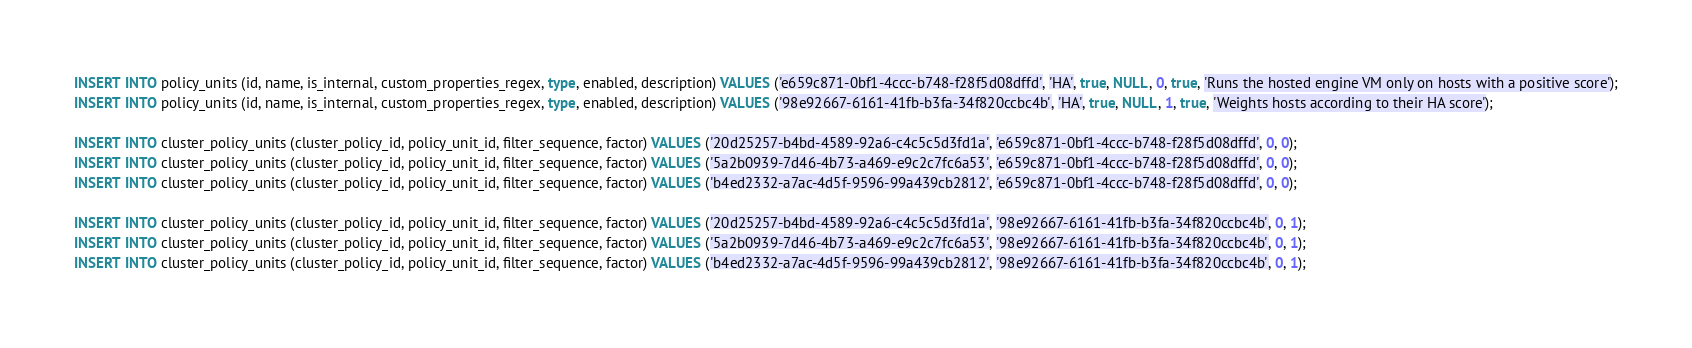Convert code to text. <code><loc_0><loc_0><loc_500><loc_500><_SQL_>
INSERT INTO policy_units (id, name, is_internal, custom_properties_regex, type, enabled, description) VALUES ('e659c871-0bf1-4ccc-b748-f28f5d08dffd', 'HA', true, NULL, 0, true, 'Runs the hosted engine VM only on hosts with a positive score');
INSERT INTO policy_units (id, name, is_internal, custom_properties_regex, type, enabled, description) VALUES ('98e92667-6161-41fb-b3fa-34f820ccbc4b', 'HA', true, NULL, 1, true, 'Weights hosts according to their HA score');

INSERT INTO cluster_policy_units (cluster_policy_id, policy_unit_id, filter_sequence, factor) VALUES ('20d25257-b4bd-4589-92a6-c4c5c5d3fd1a', 'e659c871-0bf1-4ccc-b748-f28f5d08dffd', 0, 0);
INSERT INTO cluster_policy_units (cluster_policy_id, policy_unit_id, filter_sequence, factor) VALUES ('5a2b0939-7d46-4b73-a469-e9c2c7fc6a53', 'e659c871-0bf1-4ccc-b748-f28f5d08dffd', 0, 0);
INSERT INTO cluster_policy_units (cluster_policy_id, policy_unit_id, filter_sequence, factor) VALUES ('b4ed2332-a7ac-4d5f-9596-99a439cb2812', 'e659c871-0bf1-4ccc-b748-f28f5d08dffd', 0, 0);

INSERT INTO cluster_policy_units (cluster_policy_id, policy_unit_id, filter_sequence, factor) VALUES ('20d25257-b4bd-4589-92a6-c4c5c5d3fd1a', '98e92667-6161-41fb-b3fa-34f820ccbc4b', 0, 1);
INSERT INTO cluster_policy_units (cluster_policy_id, policy_unit_id, filter_sequence, factor) VALUES ('5a2b0939-7d46-4b73-a469-e9c2c7fc6a53', '98e92667-6161-41fb-b3fa-34f820ccbc4b', 0, 1);
INSERT INTO cluster_policy_units (cluster_policy_id, policy_unit_id, filter_sequence, factor) VALUES ('b4ed2332-a7ac-4d5f-9596-99a439cb2812', '98e92667-6161-41fb-b3fa-34f820ccbc4b', 0, 1);
</code> 